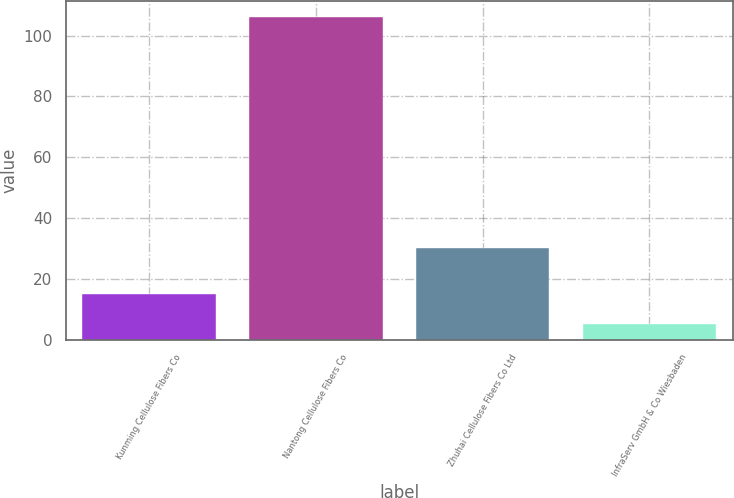Convert chart. <chart><loc_0><loc_0><loc_500><loc_500><bar_chart><fcel>Kunming Cellulose Fibers Co<fcel>Nantong Cellulose Fibers Co<fcel>Zhuhai Cellulose Fibers Co Ltd<fcel>InfraServ GmbH & Co Wiesbaden<nl><fcel>15.1<fcel>106<fcel>30<fcel>5<nl></chart> 